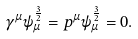<formula> <loc_0><loc_0><loc_500><loc_500>\gamma ^ { \mu } \psi _ { \mu } ^ { \frac { 3 } { 2 } } = p ^ { \mu } \psi _ { \mu } ^ { \frac { 3 } { 2 } } = 0 .</formula> 